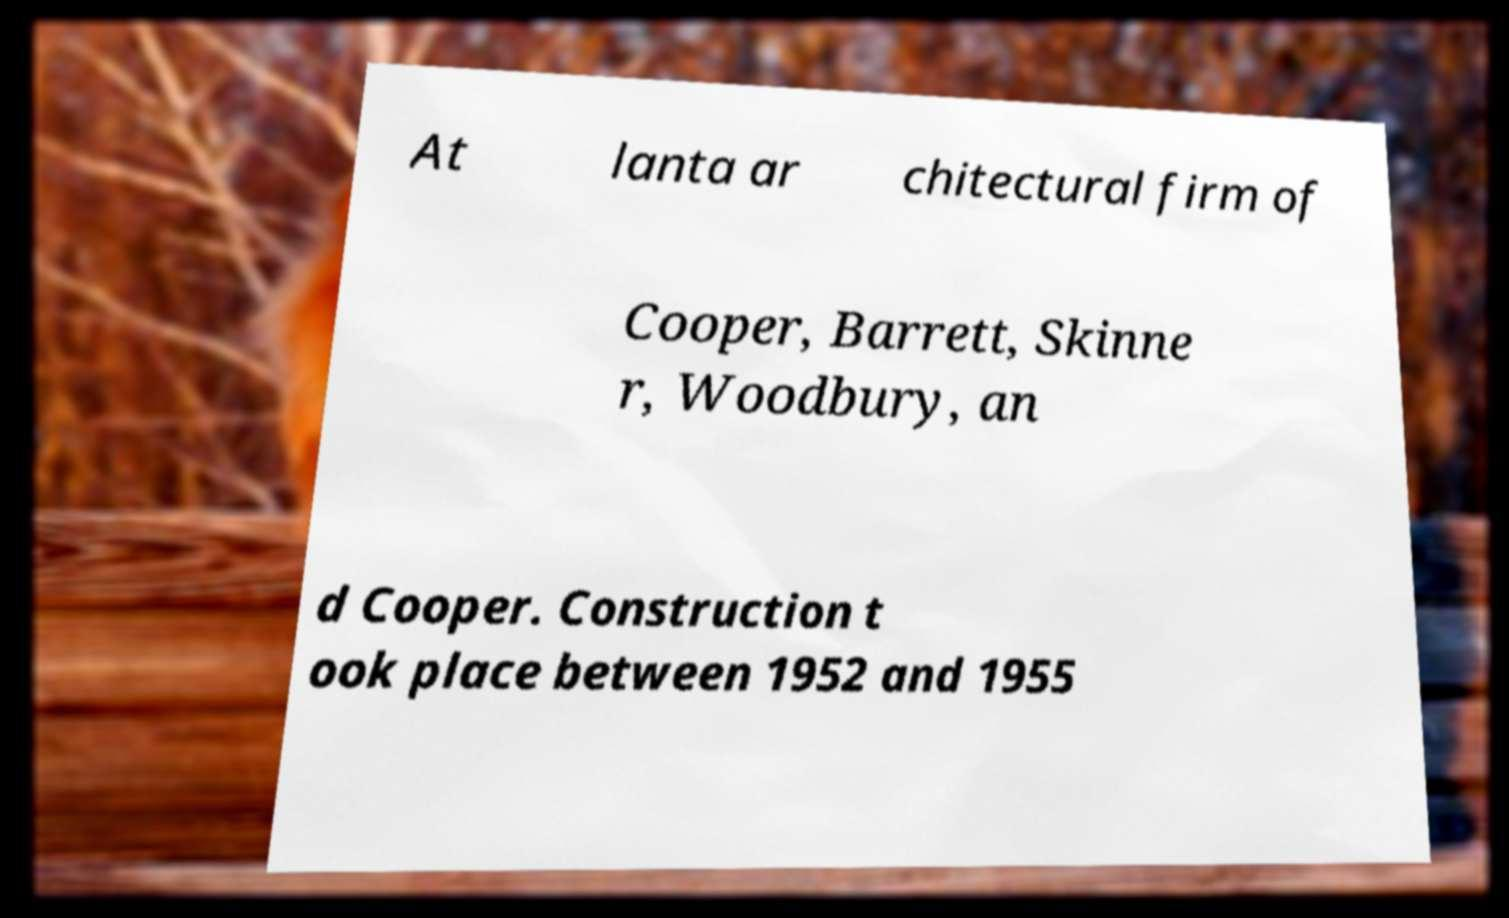Could you assist in decoding the text presented in this image and type it out clearly? At lanta ar chitectural firm of Cooper, Barrett, Skinne r, Woodbury, an d Cooper. Construction t ook place between 1952 and 1955 